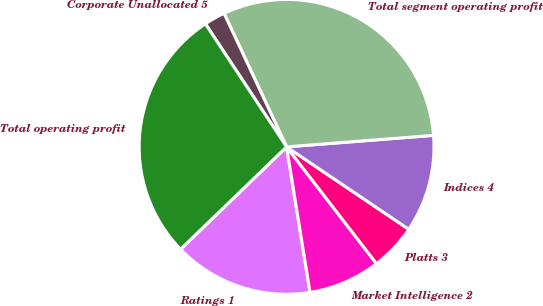Convert chart to OTSL. <chart><loc_0><loc_0><loc_500><loc_500><pie_chart><fcel>Ratings 1<fcel>Market Intelligence 2<fcel>Platts 3<fcel>Indices 4<fcel>Total segment operating profit<fcel>Corporate Unallocated 5<fcel>Total operating profit<nl><fcel>15.32%<fcel>7.9%<fcel>5.11%<fcel>10.69%<fcel>30.73%<fcel>2.31%<fcel>27.94%<nl></chart> 